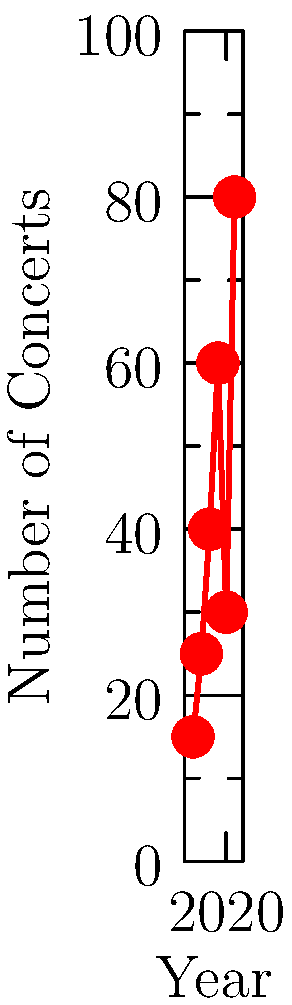As an event organizer, you're evaluating a pianist's career progression. The graph shows the number of concerts performed and average ratings received by the pianist from 2016 to 2021. Which year marked a significant turning point in the pianist's career, showing resilience and dedication to their craft despite challenges? To answer this question, we need to analyze the trends in both the number of concerts and average ratings:

1. From 2016 to 2019, there's a steady increase in both concerts and ratings.
2. In 2020, there's a sharp drop in the number of concerts (from 60 to 30), likely due to the global pandemic.
3. However, the average rating in 2020 only slightly decreased (from 4.5 to 4.3).
4. In 2021, there's a dramatic increase in concerts (from 30 to 80) and ratings (from 4.3 to 4.7).

The turning point is 2021 because:
a) It shows the pianist's resilience in bouncing back from the challenges of 2020.
b) The number of concerts reached its highest point (80), significantly surpassing pre-pandemic levels.
c) The average rating also reached its peak (4.7), indicating improved performance quality.

This demonstrates the pianist's dedication to their craft, ability to adapt to challenges, and commitment to bringing joy through music, which aligns with the event organizer's appreciation for such qualities.
Answer: 2021 